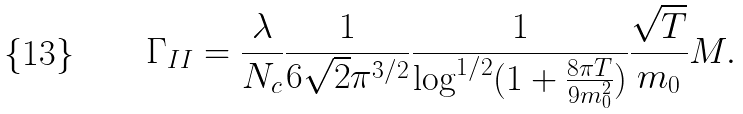Convert formula to latex. <formula><loc_0><loc_0><loc_500><loc_500>\Gamma _ { I I } = \frac { \lambda } { N _ { c } } \frac { 1 } { 6 \sqrt { 2 } \pi ^ { 3 / 2 } } \frac { 1 } { \log ^ { 1 / 2 } ( 1 + \frac { 8 \pi T } { 9 m _ { 0 } ^ { 2 } } ) } \frac { \sqrt { T } } { m _ { 0 } } M .</formula> 